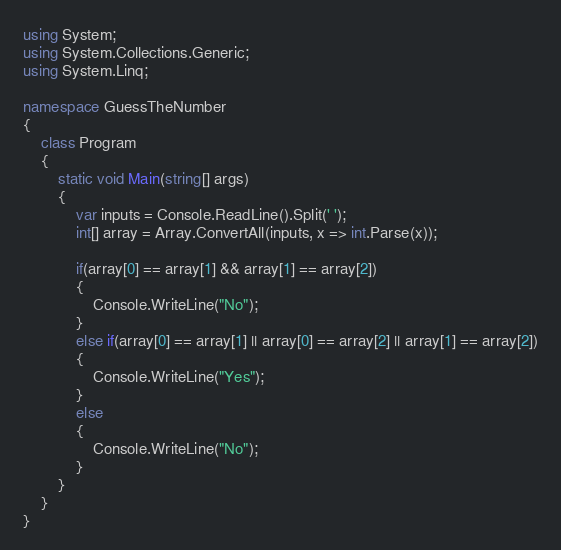Convert code to text. <code><loc_0><loc_0><loc_500><loc_500><_C#_>using System;
using System.Collections.Generic;
using System.Linq;

namespace GuessTheNumber
{
    class Program
    {
        static void Main(string[] args)
        {
            var inputs = Console.ReadLine().Split(' ');
            int[] array = Array.ConvertAll(inputs, x => int.Parse(x));

            if(array[0] == array[1] && array[1] == array[2])
            {
                Console.WriteLine("No");
            }
            else if(array[0] == array[1] || array[0] == array[2] || array[1] == array[2])
            {
                Console.WriteLine("Yes");
            }
            else
            {
                Console.WriteLine("No");
            }
        }
    }
}
</code> 